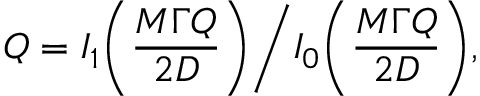Convert formula to latex. <formula><loc_0><loc_0><loc_500><loc_500>Q = I _ { 1 } \left ( \frac { M \Gamma Q } { 2 D } \right ) \Big / I _ { 0 } \left ( \frac { M \Gamma Q } { 2 D } \right ) ,</formula> 